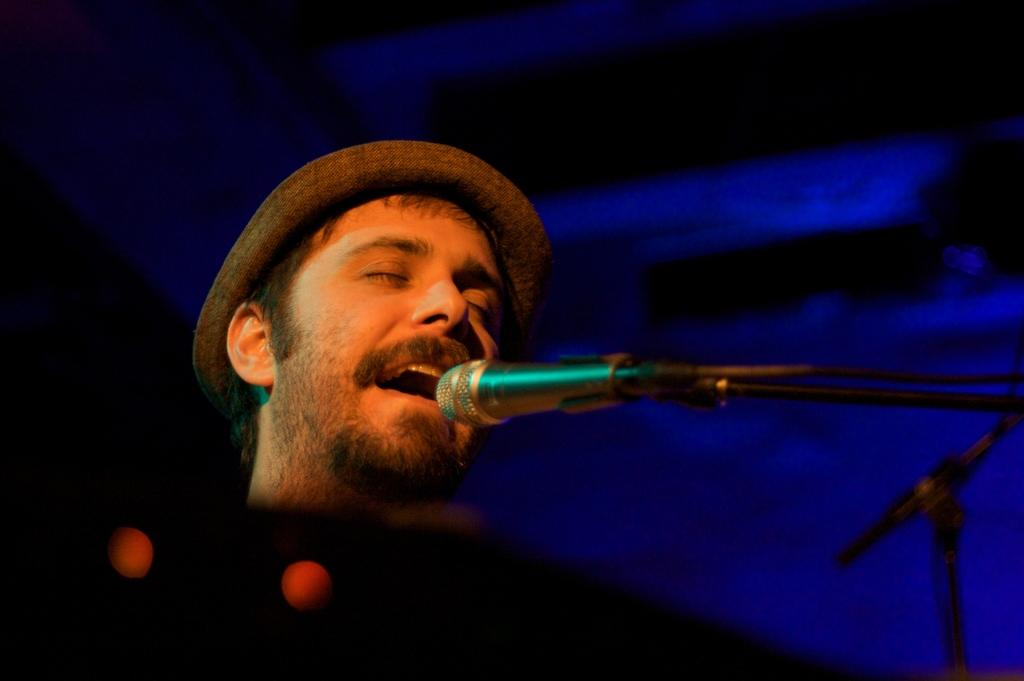What is the main subject of the image? There is a person in the image. What is the person wearing on their head? The person is wearing a cap. What is the person doing in the image? The person is singing. What object is present for amplifying the person's voice? There is a microphone in the image, and it is attached to a stand. How would you describe the background of the image? The background of the image is dark in color. How many rings can be seen on the person's fingers in the image? There are no rings visible on the person's fingers in the image. Is there a seat for the person to rest in the image? There is no seat present in the image. 